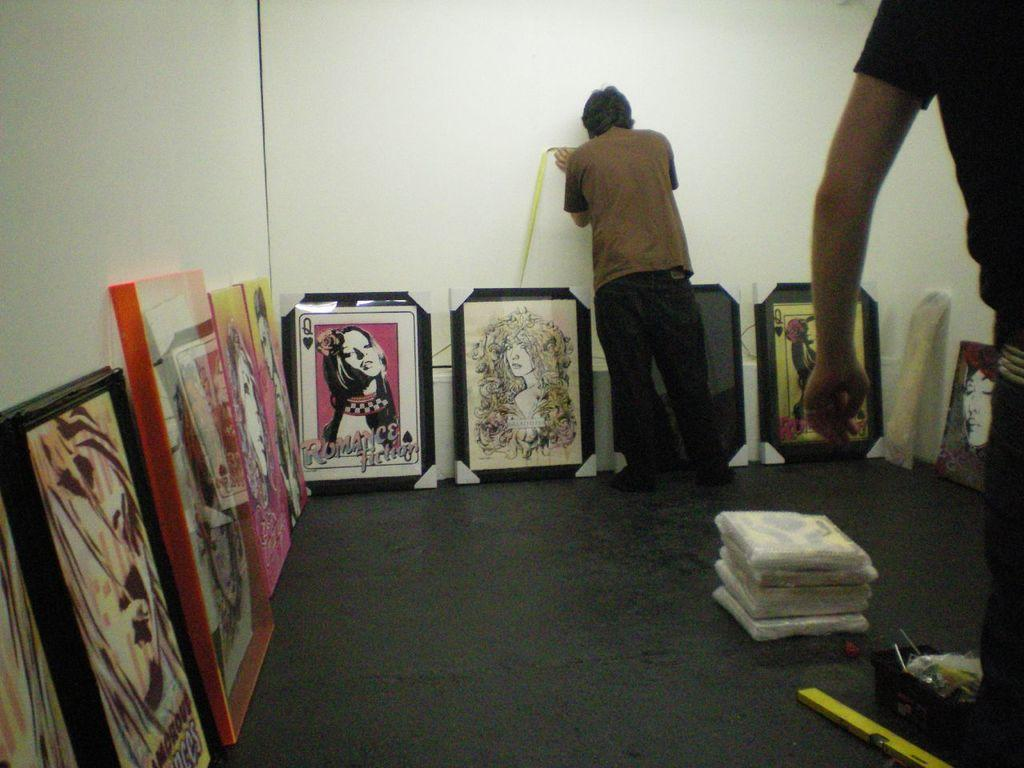<image>
Render a clear and concise summary of the photo. Several paintings and posters are laid against a wall, including one that says Romance Fiction. 